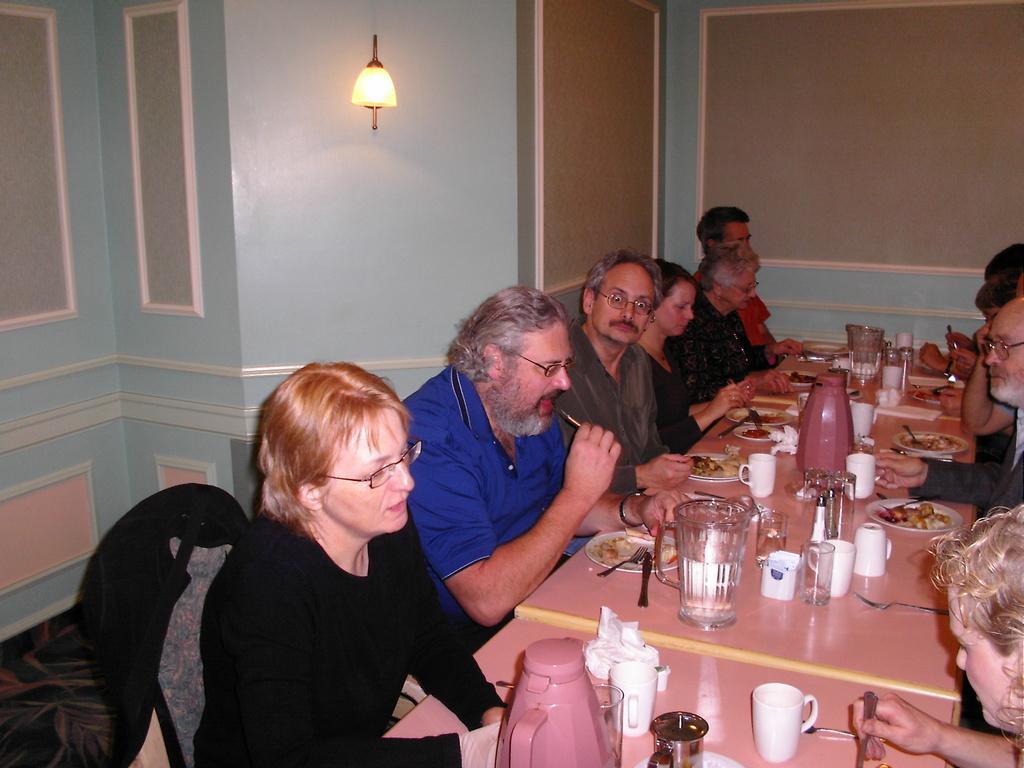Please provide a concise description of this image. In this picture we can see some people sitting on chairs in front of tables, we can see plates, glasses, cups, kettles, jars, spoons and forks present on these tables, in the background there is a wall, we can see a lamp here. 